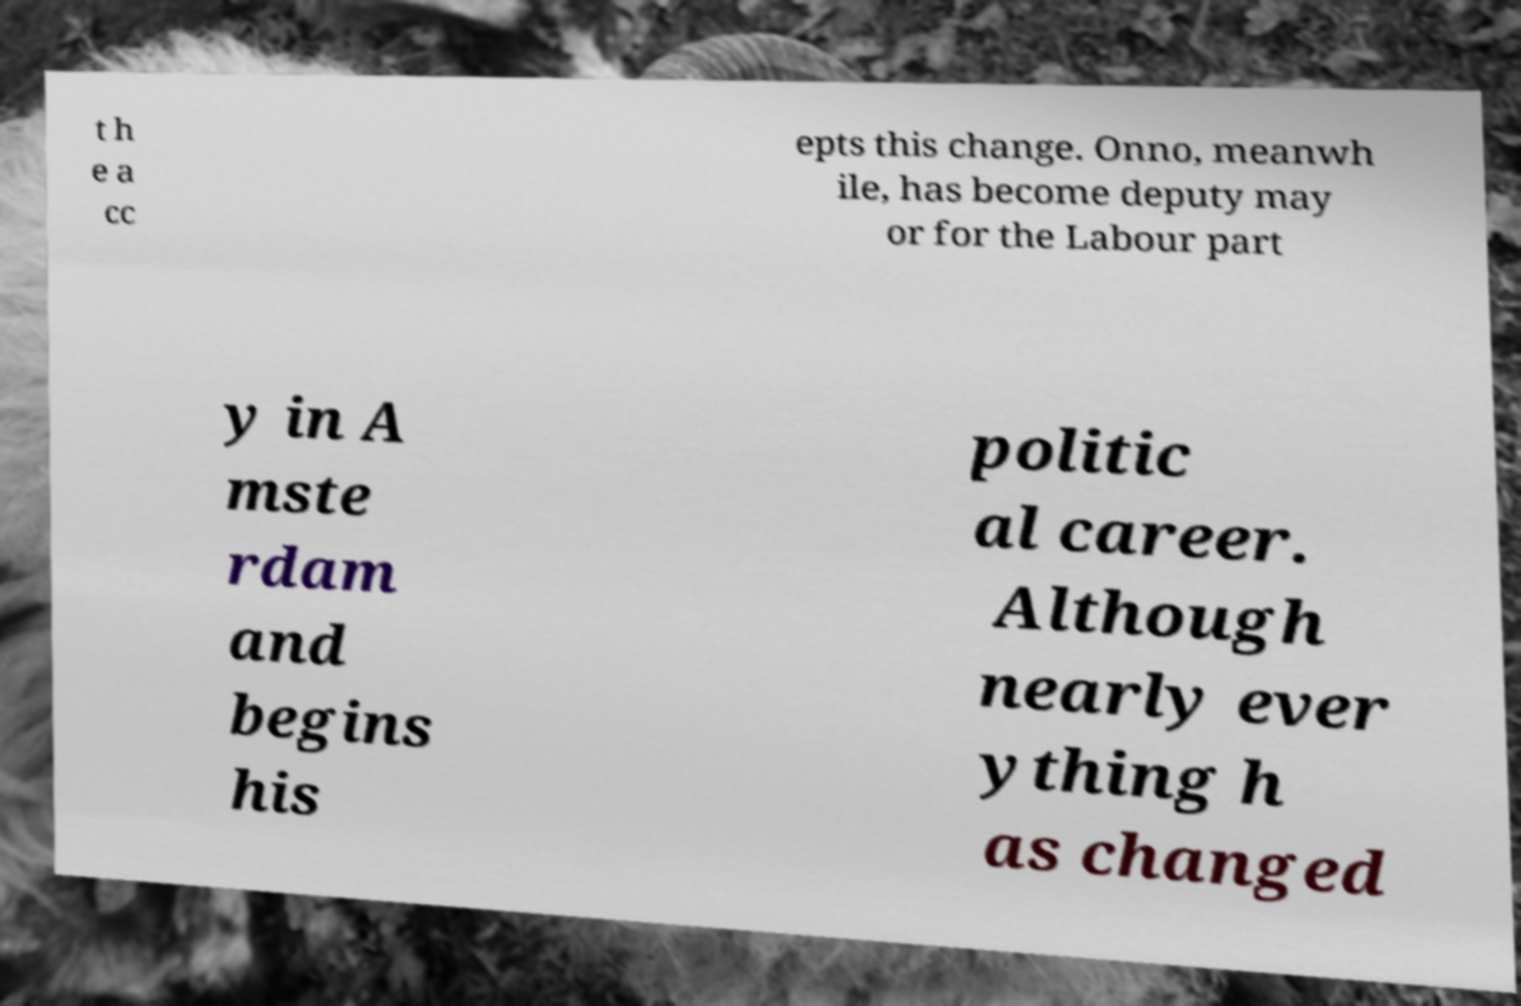There's text embedded in this image that I need extracted. Can you transcribe it verbatim? t h e a cc epts this change. Onno, meanwh ile, has become deputy may or for the Labour part y in A mste rdam and begins his politic al career. Although nearly ever ything h as changed 